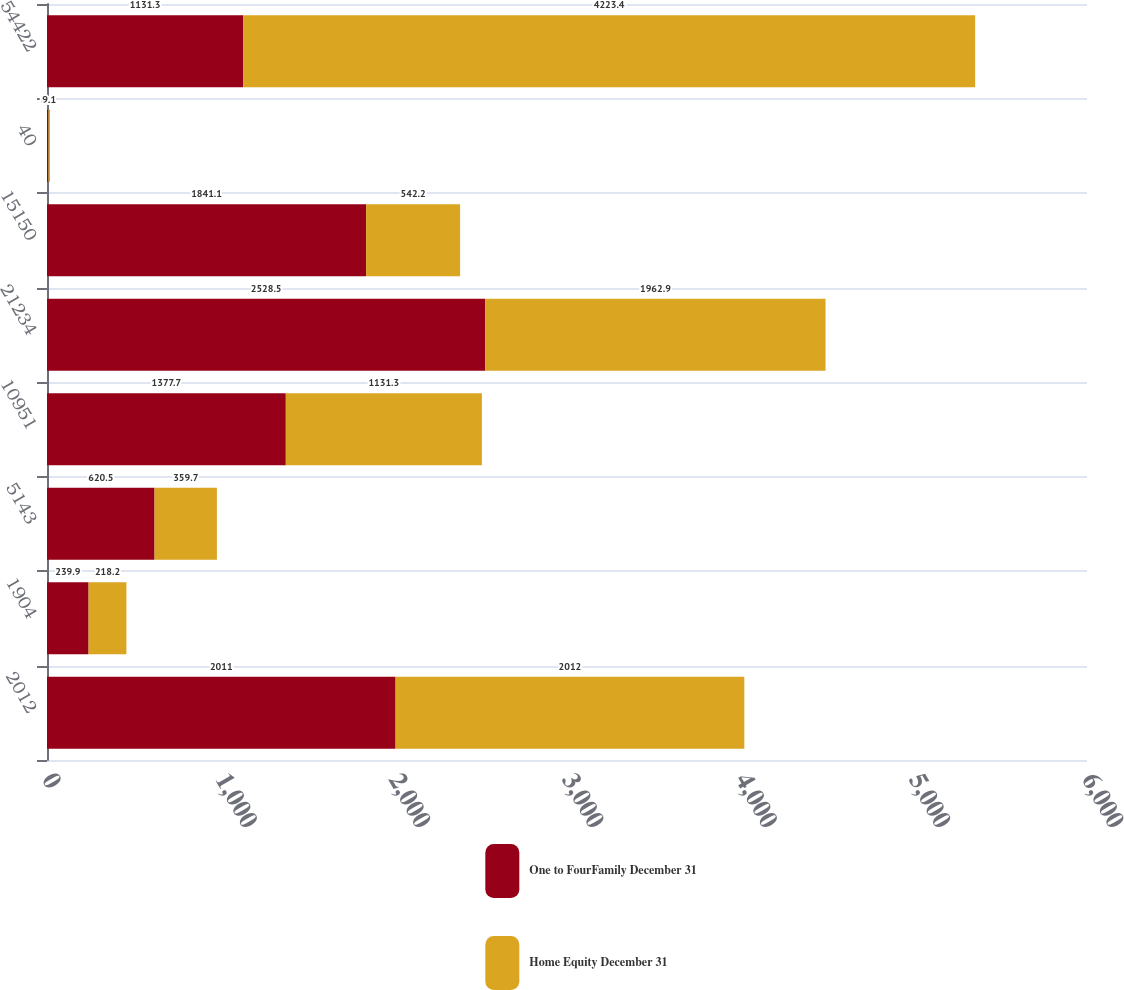Convert chart. <chart><loc_0><loc_0><loc_500><loc_500><stacked_bar_chart><ecel><fcel>2012<fcel>1904<fcel>5143<fcel>10951<fcel>21234<fcel>15150<fcel>40<fcel>54422<nl><fcel>One to FourFamily December 31<fcel>2011<fcel>239.9<fcel>620.5<fcel>1377.7<fcel>2528.5<fcel>1841.1<fcel>8.1<fcel>1131.3<nl><fcel>Home Equity December 31<fcel>2012<fcel>218.2<fcel>359.7<fcel>1131.3<fcel>1962.9<fcel>542.2<fcel>9.1<fcel>4223.4<nl></chart> 